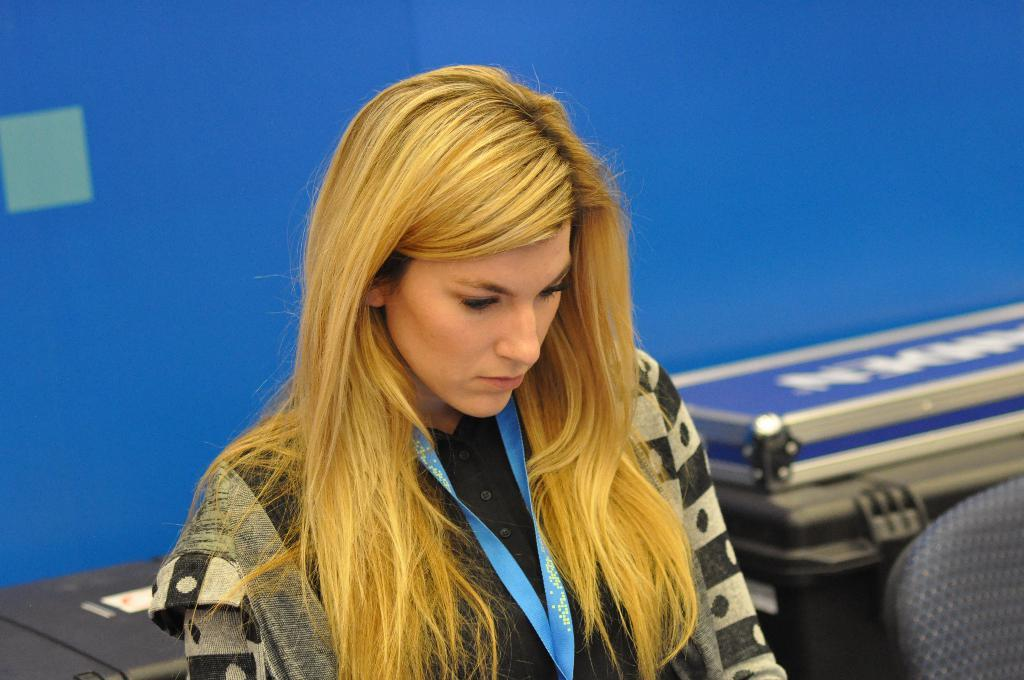Who is the main subject in the image? There is a girl in the image. What is the girl doing in the image? The girl is sitting on a chair. What can be seen in the background of the image? There is a wall in the background of the image. Can you see any grass growing on the earth in the image? There is no grass or earth visible in the image; it only features a girl sitting on a chair with a wall in the background. 